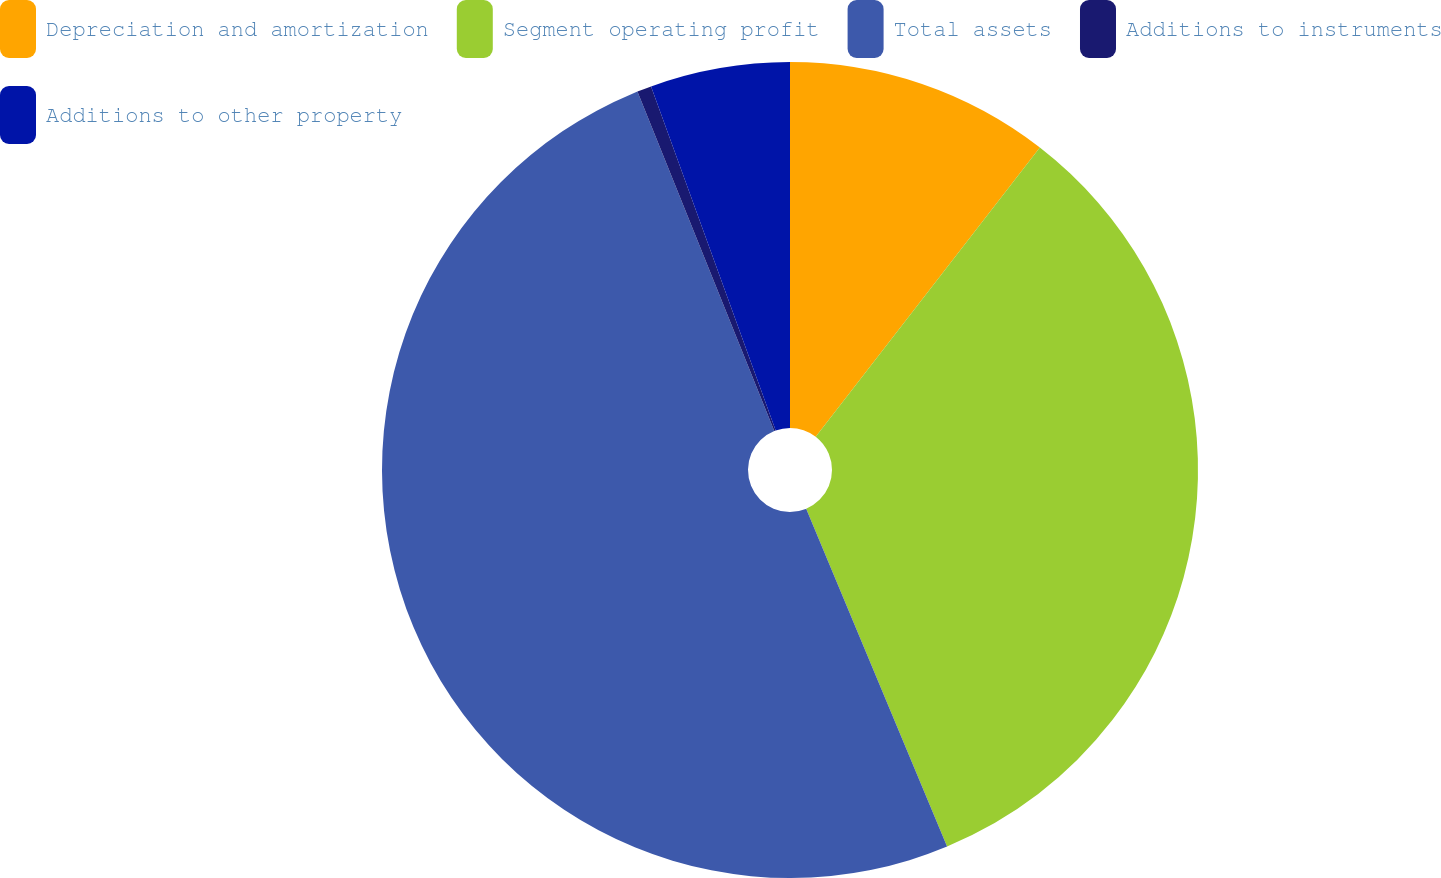Convert chart. <chart><loc_0><loc_0><loc_500><loc_500><pie_chart><fcel>Depreciation and amortization<fcel>Segment operating profit<fcel>Total assets<fcel>Additions to instruments<fcel>Additions to other property<nl><fcel>10.49%<fcel>33.22%<fcel>50.19%<fcel>0.57%<fcel>5.53%<nl></chart> 